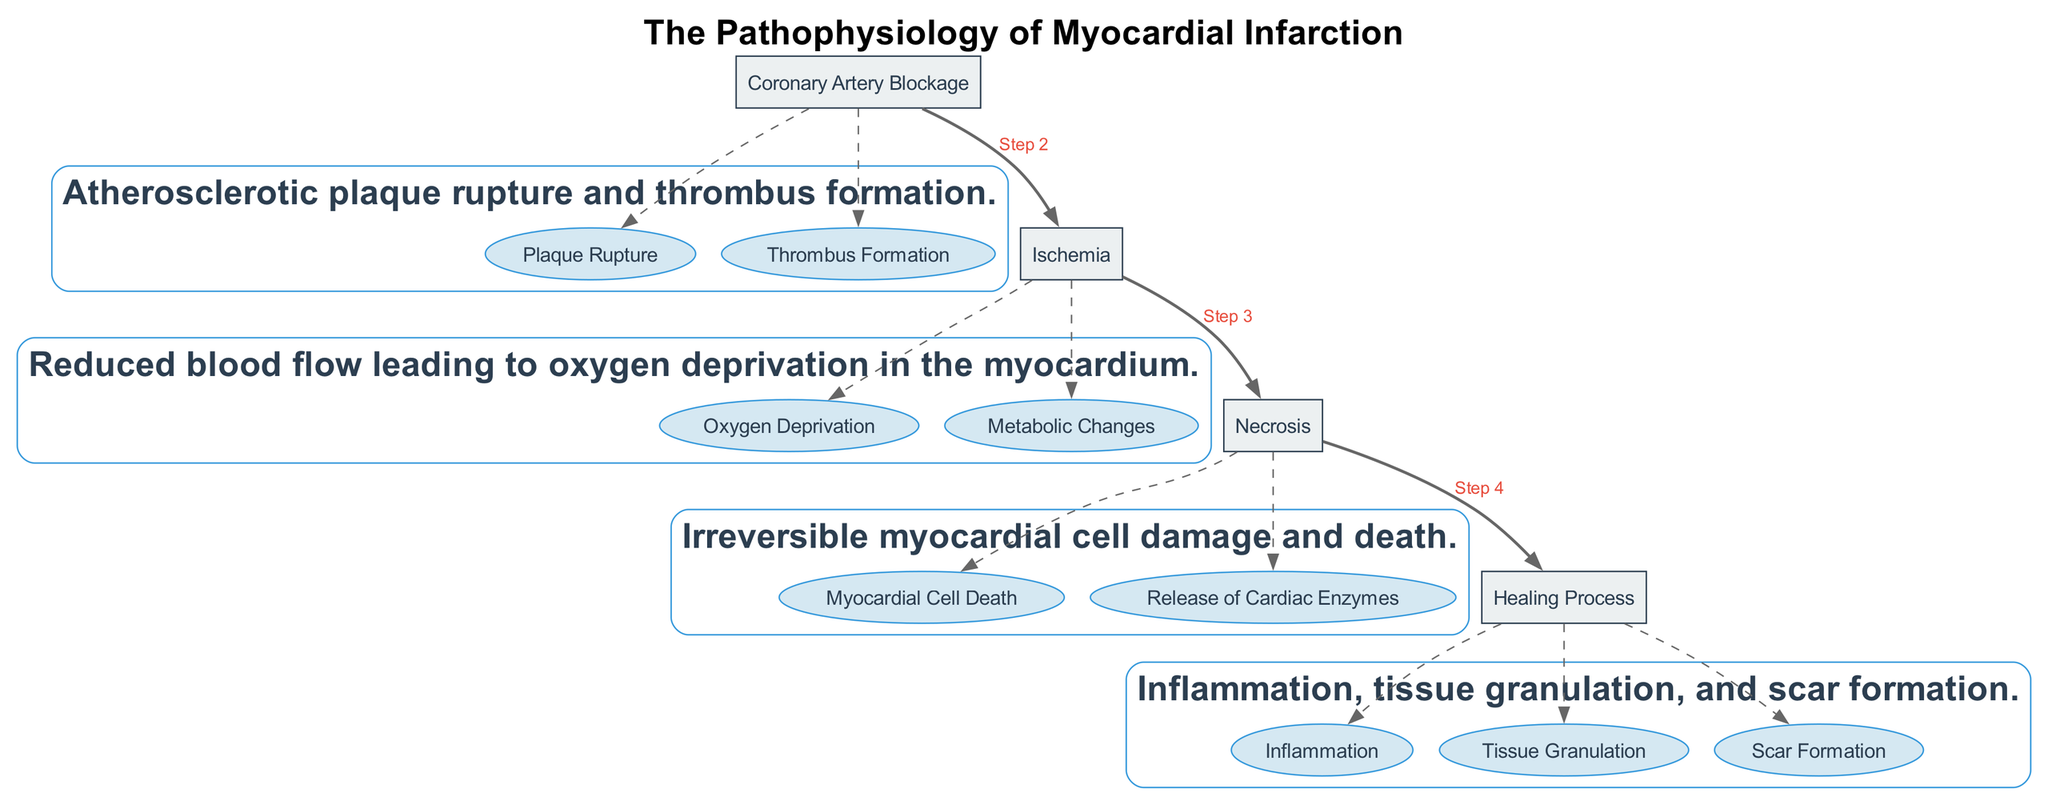What stage follows ischemia in myocardial infarction? The diagram outlines the stages of myocardial infarction. After the "Ischemia" stage, the following stage is "Necrosis" as indicated by the directed edge connecting them.
Answer: Necrosis How many detailing nodes are in the healing process stage? The "Healing Process" stage includes three detailing nodes: "Inflammation," "Tissue Granulation," and "Scar Formation," as visually represented within the cluster of this stage.
Answer: 3 What primary event occurs during coronary artery blockage? The description in the diagram for the "Coronary Artery Blockage" stage highlights "Atherosclerotic plaque rupture and thrombus formation," indicating the primary event leading to this blockage.
Answer: Atherosclerotic plaque rupture Which node leads to the release of cardiac enzymes? The diagram shows that within the "Necrosis" stage, the detailing node "Release of Cardiac Enzymes" directly describes an event that occurs following myocardial cell death.
Answer: Release of Cardiac Enzymes What is the immediate response of the blood vessel in hemostasis? The "Vascular Spasm" stage in the diagram indicates that immediate constriction of the blood vessel occurs as a response to injury, thus characterizing this initial step in hemostasis.
Answer: Immediate constriction What are the two key pathways involved in the coagulation cascade? The "Coagulation Cascade" stage details include "Intrinsic Pathway" and "Extrinsic Pathway," which are the two critical pathways that activate the clotting process sequentially.
Answer: Intrinsic Pathway and Extrinsic Pathway What process is indicated by the node following extravasation in metastasis? After "Extravasation," the next phase indicated in the diagram is "Colonization at Secondary Site," showing the progression of cancer cells after they exit the bloodstream into new tissues.
Answer: Colonization at Secondary Site Which node signifies the initiation of pain perception? The first node in the diagram related to the neural pathways of pain perception is "Nociceptors," which are responsible for detecting harmful stimuli and initiating the pain sensation process.
Answer: Nociceptors What is the last step in the hemostasis process depicted? The last step in the diagram sequence for hemostasis is "Fibrin Mesh Development," indicating the formation of a stable blood clot which occurs after all previous stages have been completed.
Answer: Fibrin Mesh Development 